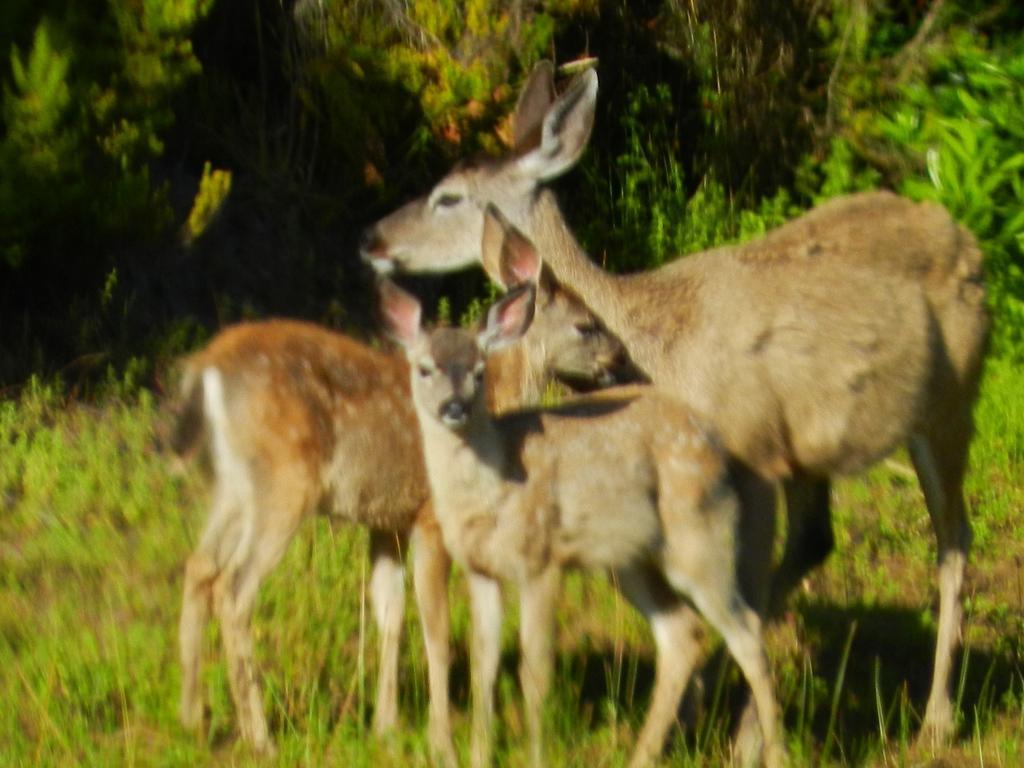How would you summarize this image in a sentence or two? In this image there are three deer standing on the ground. There is the grass on the ground. Behind them there are plants. 